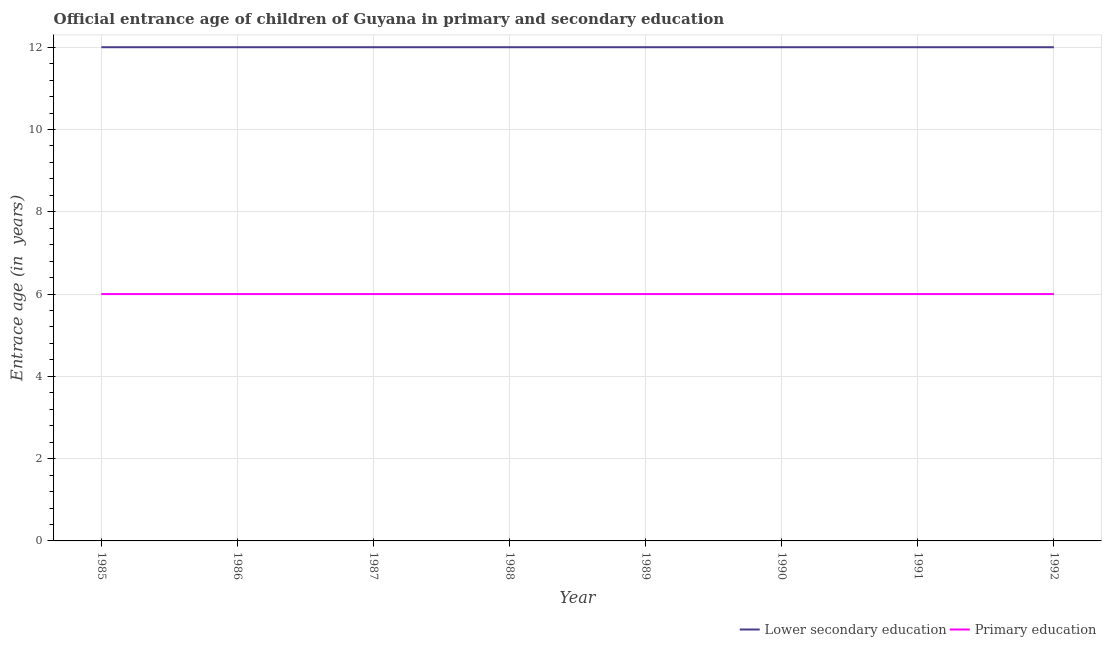What is the entrance age of children in lower secondary education in 1988?
Your response must be concise. 12. Across all years, what is the maximum entrance age of children in lower secondary education?
Ensure brevity in your answer.  12. Across all years, what is the minimum entrance age of children in lower secondary education?
Your answer should be compact. 12. In which year was the entrance age of children in lower secondary education minimum?
Your answer should be very brief. 1985. What is the total entrance age of children in lower secondary education in the graph?
Keep it short and to the point. 96. What is the difference between the entrance age of chiildren in primary education in 1990 and that in 1991?
Ensure brevity in your answer.  0. What is the average entrance age of children in lower secondary education per year?
Make the answer very short. 12. In the year 1986, what is the difference between the entrance age of chiildren in primary education and entrance age of children in lower secondary education?
Keep it short and to the point. -6. In how many years, is the entrance age of children in lower secondary education greater than 8 years?
Your answer should be compact. 8. What is the difference between the highest and the second highest entrance age of chiildren in primary education?
Ensure brevity in your answer.  0. What is the difference between the highest and the lowest entrance age of children in lower secondary education?
Keep it short and to the point. 0. Is the entrance age of chiildren in primary education strictly greater than the entrance age of children in lower secondary education over the years?
Give a very brief answer. No. Are the values on the major ticks of Y-axis written in scientific E-notation?
Keep it short and to the point. No. Does the graph contain any zero values?
Your response must be concise. No. Does the graph contain grids?
Ensure brevity in your answer.  Yes. How many legend labels are there?
Keep it short and to the point. 2. What is the title of the graph?
Make the answer very short. Official entrance age of children of Guyana in primary and secondary education. Does "Urban" appear as one of the legend labels in the graph?
Provide a succinct answer. No. What is the label or title of the X-axis?
Give a very brief answer. Year. What is the label or title of the Y-axis?
Provide a succinct answer. Entrace age (in  years). What is the Entrace age (in  years) in Lower secondary education in 1985?
Your answer should be compact. 12. What is the Entrace age (in  years) of Primary education in 1987?
Your answer should be compact. 6. What is the Entrace age (in  years) of Primary education in 1991?
Your answer should be compact. 6. Across all years, what is the minimum Entrace age (in  years) of Primary education?
Offer a very short reply. 6. What is the total Entrace age (in  years) of Lower secondary education in the graph?
Provide a short and direct response. 96. What is the total Entrace age (in  years) in Primary education in the graph?
Provide a short and direct response. 48. What is the difference between the Entrace age (in  years) of Lower secondary education in 1985 and that in 1987?
Your answer should be very brief. 0. What is the difference between the Entrace age (in  years) in Primary education in 1985 and that in 1987?
Your answer should be very brief. 0. What is the difference between the Entrace age (in  years) of Lower secondary education in 1985 and that in 1988?
Your response must be concise. 0. What is the difference between the Entrace age (in  years) in Lower secondary education in 1985 and that in 1989?
Ensure brevity in your answer.  0. What is the difference between the Entrace age (in  years) in Primary education in 1985 and that in 1990?
Your response must be concise. 0. What is the difference between the Entrace age (in  years) in Lower secondary education in 1985 and that in 1991?
Provide a short and direct response. 0. What is the difference between the Entrace age (in  years) in Lower secondary education in 1985 and that in 1992?
Ensure brevity in your answer.  0. What is the difference between the Entrace age (in  years) of Primary education in 1985 and that in 1992?
Your response must be concise. 0. What is the difference between the Entrace age (in  years) of Lower secondary education in 1986 and that in 1987?
Provide a short and direct response. 0. What is the difference between the Entrace age (in  years) in Primary education in 1986 and that in 1987?
Your response must be concise. 0. What is the difference between the Entrace age (in  years) of Lower secondary education in 1986 and that in 1988?
Offer a terse response. 0. What is the difference between the Entrace age (in  years) of Lower secondary education in 1986 and that in 1990?
Keep it short and to the point. 0. What is the difference between the Entrace age (in  years) of Primary education in 1986 and that in 1990?
Your answer should be compact. 0. What is the difference between the Entrace age (in  years) in Lower secondary education in 1986 and that in 1991?
Make the answer very short. 0. What is the difference between the Entrace age (in  years) in Primary education in 1986 and that in 1991?
Your answer should be compact. 0. What is the difference between the Entrace age (in  years) in Lower secondary education in 1986 and that in 1992?
Provide a succinct answer. 0. What is the difference between the Entrace age (in  years) of Primary education in 1986 and that in 1992?
Provide a short and direct response. 0. What is the difference between the Entrace age (in  years) in Lower secondary education in 1987 and that in 1989?
Offer a terse response. 0. What is the difference between the Entrace age (in  years) in Primary education in 1987 and that in 1989?
Provide a short and direct response. 0. What is the difference between the Entrace age (in  years) of Primary education in 1987 and that in 1990?
Provide a short and direct response. 0. What is the difference between the Entrace age (in  years) in Lower secondary education in 1987 and that in 1991?
Offer a terse response. 0. What is the difference between the Entrace age (in  years) in Primary education in 1987 and that in 1991?
Ensure brevity in your answer.  0. What is the difference between the Entrace age (in  years) of Primary education in 1987 and that in 1992?
Offer a terse response. 0. What is the difference between the Entrace age (in  years) in Lower secondary education in 1988 and that in 1990?
Keep it short and to the point. 0. What is the difference between the Entrace age (in  years) in Lower secondary education in 1988 and that in 1991?
Your response must be concise. 0. What is the difference between the Entrace age (in  years) of Lower secondary education in 1988 and that in 1992?
Offer a very short reply. 0. What is the difference between the Entrace age (in  years) in Primary education in 1988 and that in 1992?
Provide a short and direct response. 0. What is the difference between the Entrace age (in  years) in Lower secondary education in 1989 and that in 1991?
Keep it short and to the point. 0. What is the difference between the Entrace age (in  years) in Lower secondary education in 1990 and that in 1991?
Give a very brief answer. 0. What is the difference between the Entrace age (in  years) of Primary education in 1990 and that in 1991?
Provide a succinct answer. 0. What is the difference between the Entrace age (in  years) in Lower secondary education in 1990 and that in 1992?
Your answer should be very brief. 0. What is the difference between the Entrace age (in  years) in Primary education in 1990 and that in 1992?
Your answer should be compact. 0. What is the difference between the Entrace age (in  years) in Lower secondary education in 1991 and that in 1992?
Offer a very short reply. 0. What is the difference between the Entrace age (in  years) in Lower secondary education in 1985 and the Entrace age (in  years) in Primary education in 1986?
Your response must be concise. 6. What is the difference between the Entrace age (in  years) of Lower secondary education in 1985 and the Entrace age (in  years) of Primary education in 1987?
Keep it short and to the point. 6. What is the difference between the Entrace age (in  years) of Lower secondary education in 1985 and the Entrace age (in  years) of Primary education in 1991?
Give a very brief answer. 6. What is the difference between the Entrace age (in  years) in Lower secondary education in 1985 and the Entrace age (in  years) in Primary education in 1992?
Your answer should be very brief. 6. What is the difference between the Entrace age (in  years) of Lower secondary education in 1986 and the Entrace age (in  years) of Primary education in 1991?
Keep it short and to the point. 6. What is the difference between the Entrace age (in  years) in Lower secondary education in 1987 and the Entrace age (in  years) in Primary education in 1989?
Give a very brief answer. 6. What is the difference between the Entrace age (in  years) in Lower secondary education in 1987 and the Entrace age (in  years) in Primary education in 1991?
Your response must be concise. 6. What is the difference between the Entrace age (in  years) in Lower secondary education in 1987 and the Entrace age (in  years) in Primary education in 1992?
Offer a terse response. 6. What is the difference between the Entrace age (in  years) in Lower secondary education in 1988 and the Entrace age (in  years) in Primary education in 1990?
Your answer should be compact. 6. What is the difference between the Entrace age (in  years) of Lower secondary education in 1988 and the Entrace age (in  years) of Primary education in 1991?
Keep it short and to the point. 6. What is the difference between the Entrace age (in  years) of Lower secondary education in 1989 and the Entrace age (in  years) of Primary education in 1990?
Offer a very short reply. 6. What is the difference between the Entrace age (in  years) of Lower secondary education in 1989 and the Entrace age (in  years) of Primary education in 1992?
Give a very brief answer. 6. What is the difference between the Entrace age (in  years) of Lower secondary education in 1990 and the Entrace age (in  years) of Primary education in 1991?
Provide a short and direct response. 6. What is the average Entrace age (in  years) of Primary education per year?
Keep it short and to the point. 6. In the year 1986, what is the difference between the Entrace age (in  years) of Lower secondary education and Entrace age (in  years) of Primary education?
Your answer should be compact. 6. In the year 1987, what is the difference between the Entrace age (in  years) in Lower secondary education and Entrace age (in  years) in Primary education?
Your answer should be very brief. 6. In the year 1990, what is the difference between the Entrace age (in  years) of Lower secondary education and Entrace age (in  years) of Primary education?
Provide a succinct answer. 6. In the year 1991, what is the difference between the Entrace age (in  years) in Lower secondary education and Entrace age (in  years) in Primary education?
Your answer should be compact. 6. What is the ratio of the Entrace age (in  years) of Primary education in 1985 to that in 1986?
Ensure brevity in your answer.  1. What is the ratio of the Entrace age (in  years) in Primary education in 1985 to that in 1987?
Your answer should be very brief. 1. What is the ratio of the Entrace age (in  years) in Lower secondary education in 1985 to that in 1988?
Your answer should be compact. 1. What is the ratio of the Entrace age (in  years) in Lower secondary education in 1985 to that in 1990?
Your answer should be very brief. 1. What is the ratio of the Entrace age (in  years) of Primary education in 1985 to that in 1990?
Your answer should be very brief. 1. What is the ratio of the Entrace age (in  years) in Primary education in 1985 to that in 1991?
Offer a terse response. 1. What is the ratio of the Entrace age (in  years) in Primary education in 1985 to that in 1992?
Ensure brevity in your answer.  1. What is the ratio of the Entrace age (in  years) of Lower secondary education in 1986 to that in 1989?
Ensure brevity in your answer.  1. What is the ratio of the Entrace age (in  years) in Lower secondary education in 1986 to that in 1990?
Provide a short and direct response. 1. What is the ratio of the Entrace age (in  years) in Primary education in 1986 to that in 1990?
Your answer should be compact. 1. What is the ratio of the Entrace age (in  years) of Primary education in 1986 to that in 1991?
Offer a very short reply. 1. What is the ratio of the Entrace age (in  years) in Lower secondary education in 1986 to that in 1992?
Ensure brevity in your answer.  1. What is the ratio of the Entrace age (in  years) of Lower secondary education in 1987 to that in 1988?
Ensure brevity in your answer.  1. What is the ratio of the Entrace age (in  years) of Lower secondary education in 1987 to that in 1989?
Your response must be concise. 1. What is the ratio of the Entrace age (in  years) of Primary education in 1987 to that in 1989?
Keep it short and to the point. 1. What is the ratio of the Entrace age (in  years) in Primary education in 1987 to that in 1990?
Make the answer very short. 1. What is the ratio of the Entrace age (in  years) of Lower secondary education in 1987 to that in 1991?
Keep it short and to the point. 1. What is the ratio of the Entrace age (in  years) of Primary education in 1987 to that in 1991?
Your response must be concise. 1. What is the ratio of the Entrace age (in  years) in Lower secondary education in 1988 to that in 1989?
Offer a terse response. 1. What is the ratio of the Entrace age (in  years) in Primary education in 1988 to that in 1990?
Ensure brevity in your answer.  1. What is the ratio of the Entrace age (in  years) in Lower secondary education in 1988 to that in 1992?
Keep it short and to the point. 1. What is the ratio of the Entrace age (in  years) in Primary education in 1988 to that in 1992?
Your answer should be very brief. 1. What is the ratio of the Entrace age (in  years) in Lower secondary education in 1989 to that in 1990?
Your response must be concise. 1. What is the ratio of the Entrace age (in  years) of Primary education in 1990 to that in 1991?
Ensure brevity in your answer.  1. What is the ratio of the Entrace age (in  years) of Lower secondary education in 1990 to that in 1992?
Keep it short and to the point. 1. What is the difference between the highest and the second highest Entrace age (in  years) of Primary education?
Ensure brevity in your answer.  0. What is the difference between the highest and the lowest Entrace age (in  years) of Primary education?
Keep it short and to the point. 0. 